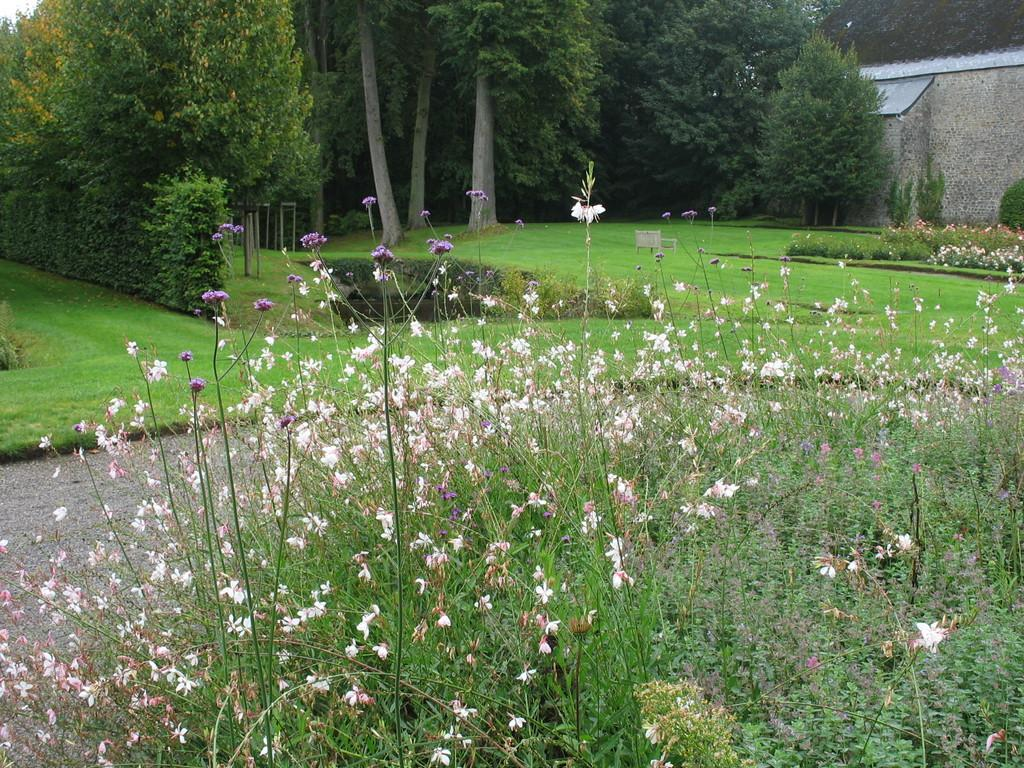What colors are the flowers in the image? The flowers in the image are white and purple in color. What can be seen in the background of the image? There are trees in the background of the image, and they are green in color. Can you describe the building in the image? The building in the image is white and gray in color. What is visible in the image? The sky is visible in the image, and it is white in color. How many drinks does the servant carry in the image? There is no servant or drinks present in the image. How many steps does the building have in the image? The image does not show the building's steps, only its color and presence. 